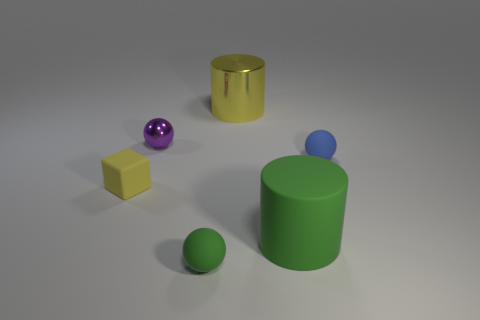There is a tiny blue object that is behind the ball that is in front of the small cube; what shape is it?
Provide a succinct answer. Sphere. There is a cylinder that is the same color as the tiny block; what is its material?
Offer a terse response. Metal. What is the color of the other large thing that is the same material as the purple thing?
Offer a very short reply. Yellow. Is there anything else that has the same size as the rubber cube?
Your response must be concise. Yes. Does the small rubber ball that is in front of the large green thing have the same color as the metal object to the right of the tiny green rubber object?
Provide a short and direct response. No. Is the number of yellow rubber cubes that are on the right side of the tiny purple shiny ball greater than the number of small blue matte spheres that are in front of the big green object?
Your response must be concise. No. There is a large metal thing that is the same shape as the big rubber thing; what is its color?
Offer a very short reply. Yellow. Are there any other things that are the same shape as the tiny metallic thing?
Your answer should be very brief. Yes. There is a purple object; does it have the same shape as the yellow thing behind the small yellow rubber thing?
Offer a very short reply. No. How many other things are there of the same material as the small cube?
Make the answer very short. 3. 